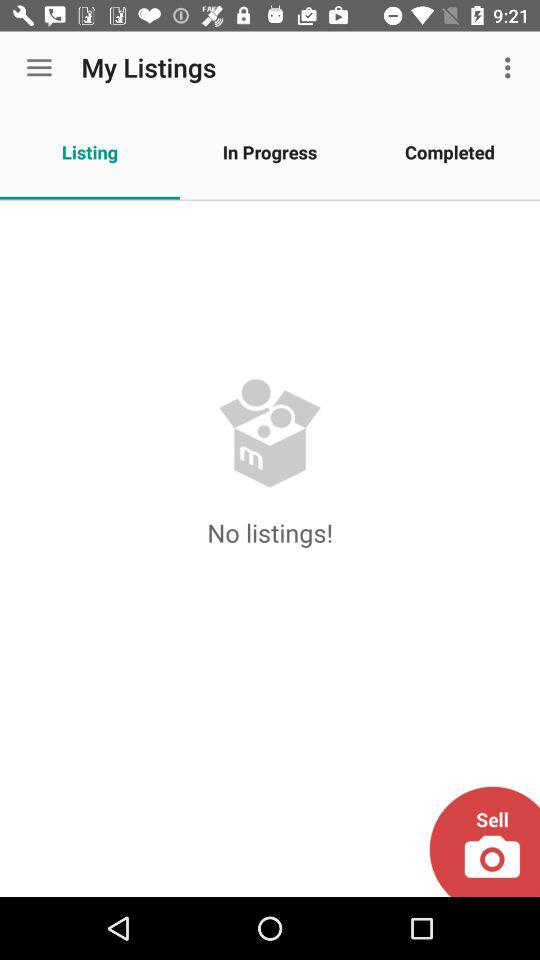What is the currently selected tab? The currently selected tab is "Listing". 